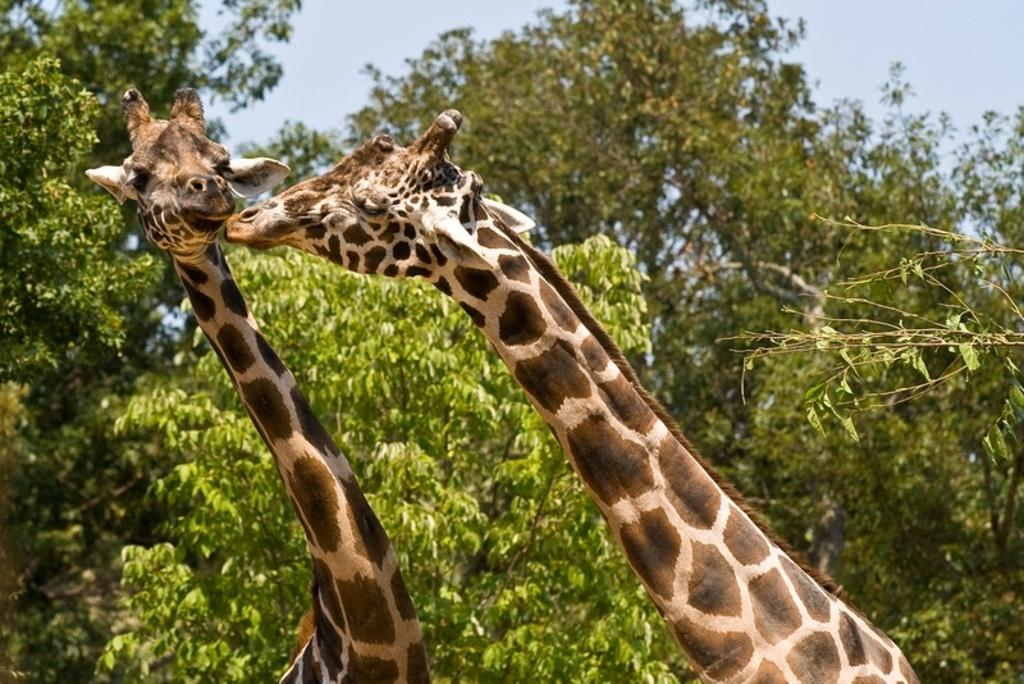How many giraffes are in the image? There are two giraffes in the image. What are the giraffes doing in the image? The giraffes are standing beside each other. What can be seen in the background of the image? There are trees in the background of the image. What is visible above the giraffes in the image? The sky is visible above the giraffes. What type of chair is the giraffe sitting on in the image? There is no chair present in the image, as the giraffes are standing beside each other. 